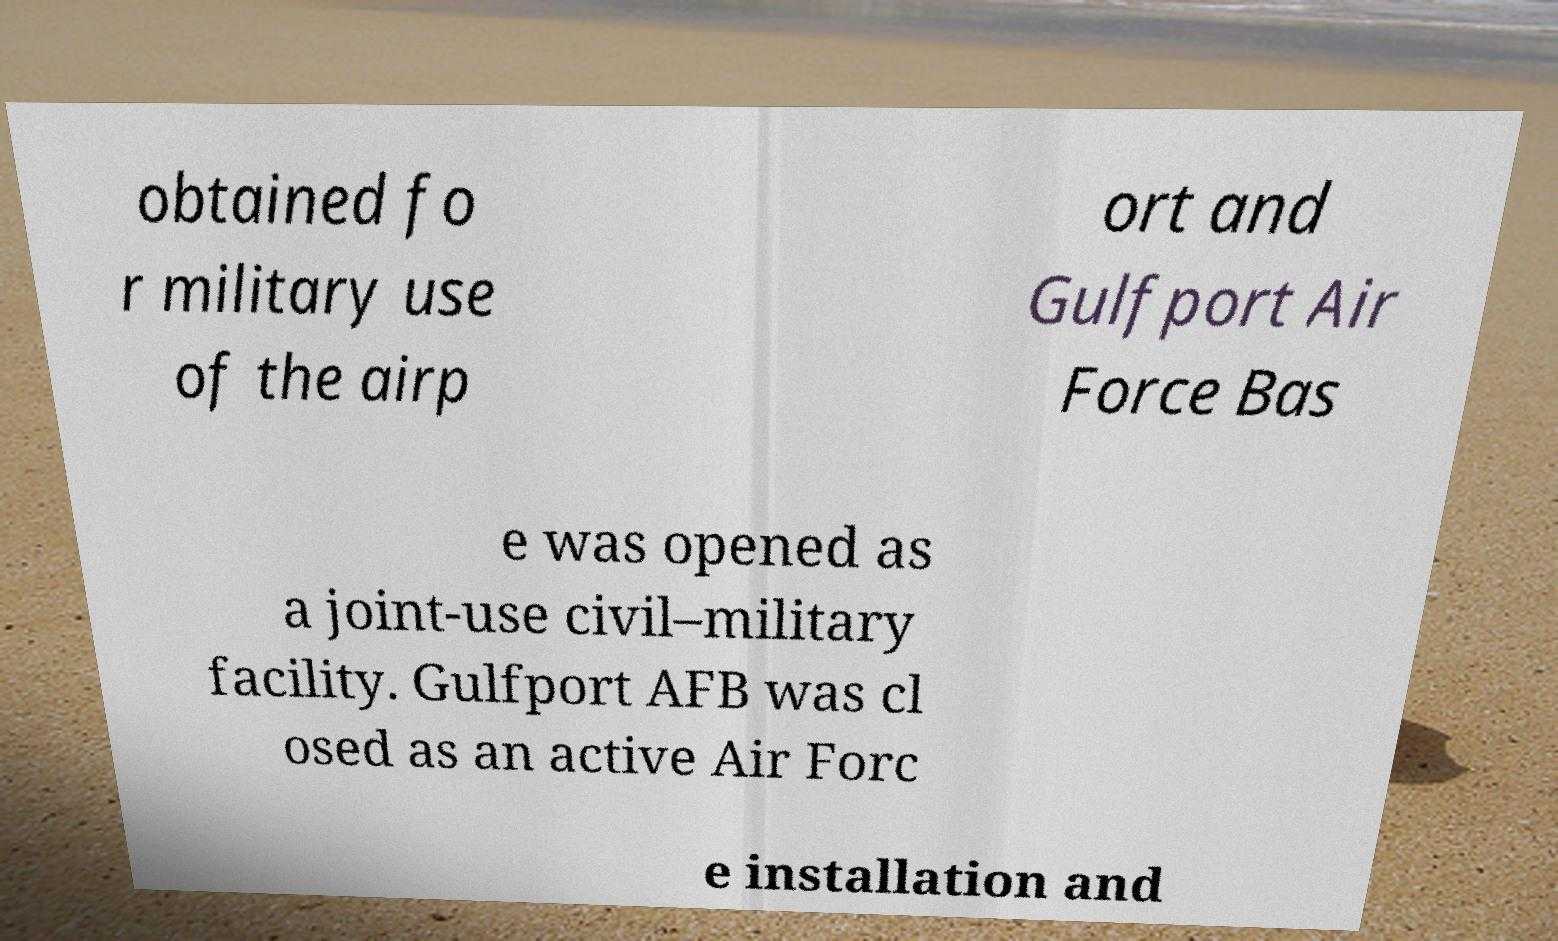There's text embedded in this image that I need extracted. Can you transcribe it verbatim? obtained fo r military use of the airp ort and Gulfport Air Force Bas e was opened as a joint-use civil–military facility. Gulfport AFB was cl osed as an active Air Forc e installation and 